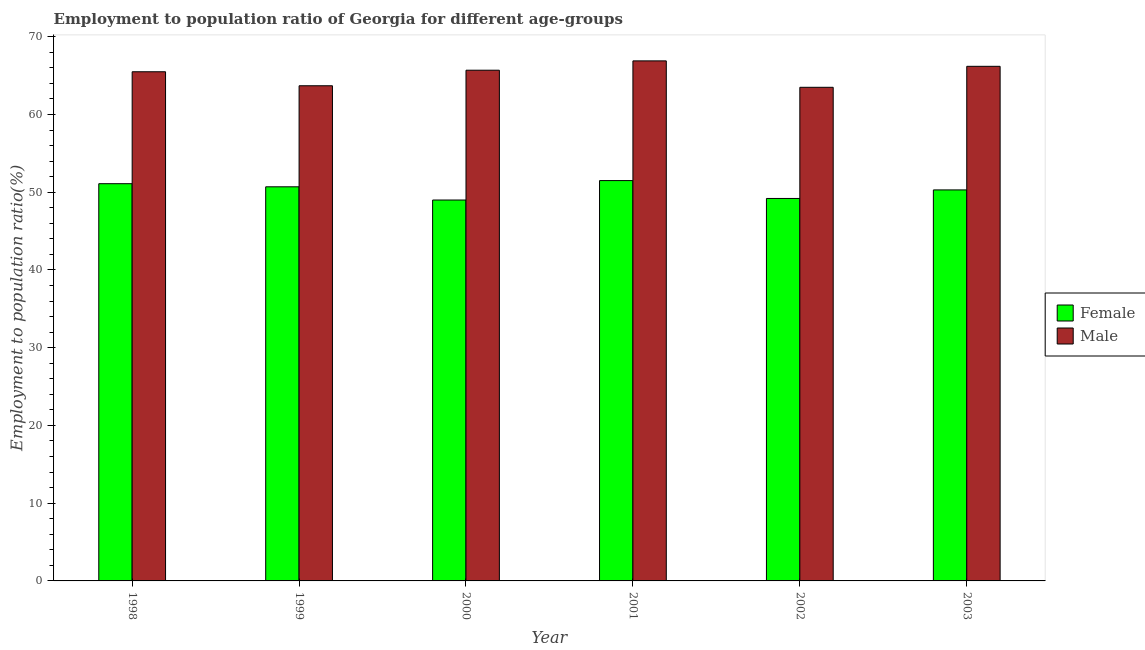How many different coloured bars are there?
Your answer should be very brief. 2. How many groups of bars are there?
Make the answer very short. 6. Are the number of bars per tick equal to the number of legend labels?
Offer a very short reply. Yes. Are the number of bars on each tick of the X-axis equal?
Provide a short and direct response. Yes. What is the employment to population ratio(female) in 1998?
Offer a very short reply. 51.1. Across all years, what is the maximum employment to population ratio(male)?
Offer a terse response. 66.9. Across all years, what is the minimum employment to population ratio(male)?
Give a very brief answer. 63.5. In which year was the employment to population ratio(male) minimum?
Offer a very short reply. 2002. What is the total employment to population ratio(male) in the graph?
Offer a terse response. 391.5. What is the difference between the employment to population ratio(male) in 1998 and that in 2003?
Your answer should be very brief. -0.7. What is the difference between the employment to population ratio(female) in 2000 and the employment to population ratio(male) in 2003?
Provide a short and direct response. -1.3. What is the average employment to population ratio(male) per year?
Provide a short and direct response. 65.25. In the year 2002, what is the difference between the employment to population ratio(male) and employment to population ratio(female)?
Provide a short and direct response. 0. In how many years, is the employment to population ratio(female) greater than 8 %?
Your response must be concise. 6. What is the ratio of the employment to population ratio(female) in 1999 to that in 2000?
Provide a short and direct response. 1.03. Is the employment to population ratio(female) in 1999 less than that in 2003?
Your answer should be very brief. No. What is the difference between the highest and the second highest employment to population ratio(male)?
Keep it short and to the point. 0.7. In how many years, is the employment to population ratio(male) greater than the average employment to population ratio(male) taken over all years?
Keep it short and to the point. 4. What does the 2nd bar from the right in 2000 represents?
Provide a short and direct response. Female. Are all the bars in the graph horizontal?
Give a very brief answer. No. Where does the legend appear in the graph?
Offer a terse response. Center right. How many legend labels are there?
Provide a succinct answer. 2. What is the title of the graph?
Offer a terse response. Employment to population ratio of Georgia for different age-groups. Does "Methane emissions" appear as one of the legend labels in the graph?
Make the answer very short. No. What is the label or title of the Y-axis?
Make the answer very short. Employment to population ratio(%). What is the Employment to population ratio(%) of Female in 1998?
Give a very brief answer. 51.1. What is the Employment to population ratio(%) in Male in 1998?
Your answer should be compact. 65.5. What is the Employment to population ratio(%) of Female in 1999?
Your response must be concise. 50.7. What is the Employment to population ratio(%) of Male in 1999?
Provide a succinct answer. 63.7. What is the Employment to population ratio(%) of Female in 2000?
Your answer should be compact. 49. What is the Employment to population ratio(%) of Male in 2000?
Keep it short and to the point. 65.7. What is the Employment to population ratio(%) of Female in 2001?
Your response must be concise. 51.5. What is the Employment to population ratio(%) in Male in 2001?
Keep it short and to the point. 66.9. What is the Employment to population ratio(%) of Female in 2002?
Offer a very short reply. 49.2. What is the Employment to population ratio(%) in Male in 2002?
Your answer should be compact. 63.5. What is the Employment to population ratio(%) in Female in 2003?
Ensure brevity in your answer.  50.3. What is the Employment to population ratio(%) of Male in 2003?
Offer a very short reply. 66.2. Across all years, what is the maximum Employment to population ratio(%) of Female?
Offer a terse response. 51.5. Across all years, what is the maximum Employment to population ratio(%) in Male?
Your response must be concise. 66.9. Across all years, what is the minimum Employment to population ratio(%) in Female?
Your answer should be compact. 49. Across all years, what is the minimum Employment to population ratio(%) in Male?
Provide a short and direct response. 63.5. What is the total Employment to population ratio(%) of Female in the graph?
Your answer should be compact. 301.8. What is the total Employment to population ratio(%) in Male in the graph?
Offer a very short reply. 391.5. What is the difference between the Employment to population ratio(%) of Male in 1998 and that in 1999?
Provide a succinct answer. 1.8. What is the difference between the Employment to population ratio(%) of Female in 1998 and that in 2000?
Give a very brief answer. 2.1. What is the difference between the Employment to population ratio(%) of Male in 1998 and that in 2000?
Your response must be concise. -0.2. What is the difference between the Employment to population ratio(%) of Female in 1998 and that in 2001?
Make the answer very short. -0.4. What is the difference between the Employment to population ratio(%) in Male in 1998 and that in 2001?
Offer a very short reply. -1.4. What is the difference between the Employment to population ratio(%) of Male in 1998 and that in 2002?
Offer a very short reply. 2. What is the difference between the Employment to population ratio(%) in Female in 1998 and that in 2003?
Provide a short and direct response. 0.8. What is the difference between the Employment to population ratio(%) in Female in 1999 and that in 2000?
Your response must be concise. 1.7. What is the difference between the Employment to population ratio(%) of Male in 1999 and that in 2000?
Offer a terse response. -2. What is the difference between the Employment to population ratio(%) in Female in 1999 and that in 2001?
Make the answer very short. -0.8. What is the difference between the Employment to population ratio(%) of Male in 1999 and that in 2001?
Your answer should be very brief. -3.2. What is the difference between the Employment to population ratio(%) of Female in 2000 and that in 2001?
Your response must be concise. -2.5. What is the difference between the Employment to population ratio(%) of Female in 2000 and that in 2002?
Provide a succinct answer. -0.2. What is the difference between the Employment to population ratio(%) in Male in 2000 and that in 2002?
Make the answer very short. 2.2. What is the difference between the Employment to population ratio(%) in Male in 2000 and that in 2003?
Your response must be concise. -0.5. What is the difference between the Employment to population ratio(%) in Female in 2001 and that in 2002?
Keep it short and to the point. 2.3. What is the difference between the Employment to population ratio(%) in Male in 2001 and that in 2003?
Offer a very short reply. 0.7. What is the difference between the Employment to population ratio(%) in Female in 2002 and that in 2003?
Your response must be concise. -1.1. What is the difference between the Employment to population ratio(%) of Female in 1998 and the Employment to population ratio(%) of Male in 1999?
Provide a succinct answer. -12.6. What is the difference between the Employment to population ratio(%) in Female in 1998 and the Employment to population ratio(%) in Male in 2000?
Your answer should be compact. -14.6. What is the difference between the Employment to population ratio(%) in Female in 1998 and the Employment to population ratio(%) in Male in 2001?
Provide a succinct answer. -15.8. What is the difference between the Employment to population ratio(%) of Female in 1998 and the Employment to population ratio(%) of Male in 2002?
Make the answer very short. -12.4. What is the difference between the Employment to population ratio(%) of Female in 1998 and the Employment to population ratio(%) of Male in 2003?
Provide a succinct answer. -15.1. What is the difference between the Employment to population ratio(%) in Female in 1999 and the Employment to population ratio(%) in Male in 2000?
Your response must be concise. -15. What is the difference between the Employment to population ratio(%) in Female in 1999 and the Employment to population ratio(%) in Male in 2001?
Your answer should be compact. -16.2. What is the difference between the Employment to population ratio(%) in Female in 1999 and the Employment to population ratio(%) in Male in 2002?
Give a very brief answer. -12.8. What is the difference between the Employment to population ratio(%) of Female in 1999 and the Employment to population ratio(%) of Male in 2003?
Provide a succinct answer. -15.5. What is the difference between the Employment to population ratio(%) in Female in 2000 and the Employment to population ratio(%) in Male in 2001?
Give a very brief answer. -17.9. What is the difference between the Employment to population ratio(%) in Female in 2000 and the Employment to population ratio(%) in Male in 2002?
Your response must be concise. -14.5. What is the difference between the Employment to population ratio(%) of Female in 2000 and the Employment to population ratio(%) of Male in 2003?
Keep it short and to the point. -17.2. What is the difference between the Employment to population ratio(%) in Female in 2001 and the Employment to population ratio(%) in Male in 2002?
Your answer should be compact. -12. What is the difference between the Employment to population ratio(%) of Female in 2001 and the Employment to population ratio(%) of Male in 2003?
Provide a short and direct response. -14.7. What is the average Employment to population ratio(%) in Female per year?
Offer a terse response. 50.3. What is the average Employment to population ratio(%) in Male per year?
Keep it short and to the point. 65.25. In the year 1998, what is the difference between the Employment to population ratio(%) in Female and Employment to population ratio(%) in Male?
Keep it short and to the point. -14.4. In the year 1999, what is the difference between the Employment to population ratio(%) of Female and Employment to population ratio(%) of Male?
Provide a short and direct response. -13. In the year 2000, what is the difference between the Employment to population ratio(%) in Female and Employment to population ratio(%) in Male?
Your response must be concise. -16.7. In the year 2001, what is the difference between the Employment to population ratio(%) of Female and Employment to population ratio(%) of Male?
Provide a short and direct response. -15.4. In the year 2002, what is the difference between the Employment to population ratio(%) of Female and Employment to population ratio(%) of Male?
Provide a succinct answer. -14.3. In the year 2003, what is the difference between the Employment to population ratio(%) of Female and Employment to population ratio(%) of Male?
Ensure brevity in your answer.  -15.9. What is the ratio of the Employment to population ratio(%) in Female in 1998 to that in 1999?
Your response must be concise. 1.01. What is the ratio of the Employment to population ratio(%) in Male in 1998 to that in 1999?
Your answer should be compact. 1.03. What is the ratio of the Employment to population ratio(%) of Female in 1998 to that in 2000?
Offer a very short reply. 1.04. What is the ratio of the Employment to population ratio(%) of Male in 1998 to that in 2000?
Offer a terse response. 1. What is the ratio of the Employment to population ratio(%) in Male in 1998 to that in 2001?
Your response must be concise. 0.98. What is the ratio of the Employment to population ratio(%) in Female in 1998 to that in 2002?
Ensure brevity in your answer.  1.04. What is the ratio of the Employment to population ratio(%) in Male in 1998 to that in 2002?
Ensure brevity in your answer.  1.03. What is the ratio of the Employment to population ratio(%) in Female in 1998 to that in 2003?
Your answer should be very brief. 1.02. What is the ratio of the Employment to population ratio(%) in Female in 1999 to that in 2000?
Provide a succinct answer. 1.03. What is the ratio of the Employment to population ratio(%) of Male in 1999 to that in 2000?
Offer a very short reply. 0.97. What is the ratio of the Employment to population ratio(%) in Female in 1999 to that in 2001?
Offer a terse response. 0.98. What is the ratio of the Employment to population ratio(%) in Male in 1999 to that in 2001?
Make the answer very short. 0.95. What is the ratio of the Employment to population ratio(%) of Female in 1999 to that in 2002?
Your answer should be compact. 1.03. What is the ratio of the Employment to population ratio(%) of Female in 1999 to that in 2003?
Offer a very short reply. 1.01. What is the ratio of the Employment to population ratio(%) of Male in 1999 to that in 2003?
Give a very brief answer. 0.96. What is the ratio of the Employment to population ratio(%) in Female in 2000 to that in 2001?
Keep it short and to the point. 0.95. What is the ratio of the Employment to population ratio(%) of Male in 2000 to that in 2001?
Offer a terse response. 0.98. What is the ratio of the Employment to population ratio(%) of Male in 2000 to that in 2002?
Offer a very short reply. 1.03. What is the ratio of the Employment to population ratio(%) of Female in 2000 to that in 2003?
Provide a succinct answer. 0.97. What is the ratio of the Employment to population ratio(%) in Female in 2001 to that in 2002?
Your response must be concise. 1.05. What is the ratio of the Employment to population ratio(%) of Male in 2001 to that in 2002?
Your answer should be very brief. 1.05. What is the ratio of the Employment to population ratio(%) of Female in 2001 to that in 2003?
Keep it short and to the point. 1.02. What is the ratio of the Employment to population ratio(%) in Male in 2001 to that in 2003?
Your response must be concise. 1.01. What is the ratio of the Employment to population ratio(%) of Female in 2002 to that in 2003?
Make the answer very short. 0.98. What is the ratio of the Employment to population ratio(%) in Male in 2002 to that in 2003?
Ensure brevity in your answer.  0.96. What is the difference between the highest and the second highest Employment to population ratio(%) of Male?
Provide a short and direct response. 0.7. What is the difference between the highest and the lowest Employment to population ratio(%) in Female?
Offer a very short reply. 2.5. What is the difference between the highest and the lowest Employment to population ratio(%) of Male?
Offer a terse response. 3.4. 